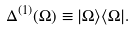<formula> <loc_0><loc_0><loc_500><loc_500>\Delta ^ { ( 1 ) } ( \Omega ) \equiv | \Omega \rangle \langle \Omega | .</formula> 